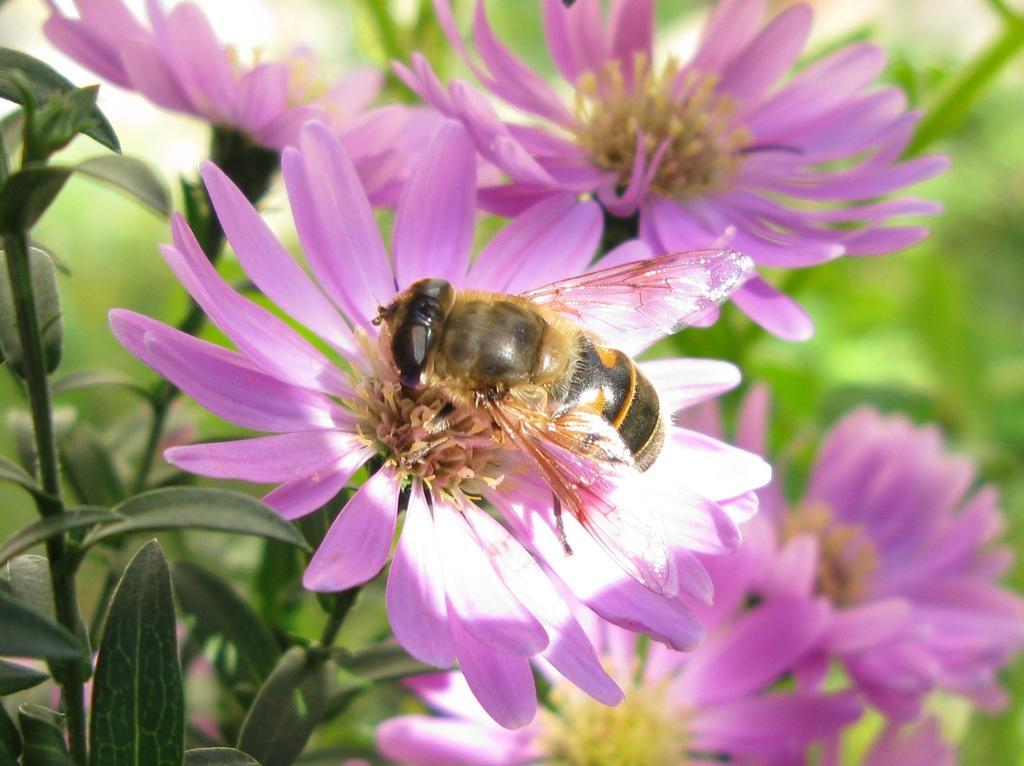Could you give a brief overview of what you see in this image? In this picture we can see a honeybee and in the background we can see plants with flowers. 